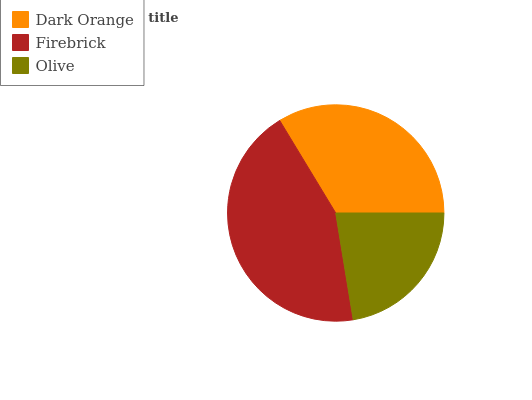Is Olive the minimum?
Answer yes or no. Yes. Is Firebrick the maximum?
Answer yes or no. Yes. Is Firebrick the minimum?
Answer yes or no. No. Is Olive the maximum?
Answer yes or no. No. Is Firebrick greater than Olive?
Answer yes or no. Yes. Is Olive less than Firebrick?
Answer yes or no. Yes. Is Olive greater than Firebrick?
Answer yes or no. No. Is Firebrick less than Olive?
Answer yes or no. No. Is Dark Orange the high median?
Answer yes or no. Yes. Is Dark Orange the low median?
Answer yes or no. Yes. Is Firebrick the high median?
Answer yes or no. No. Is Olive the low median?
Answer yes or no. No. 